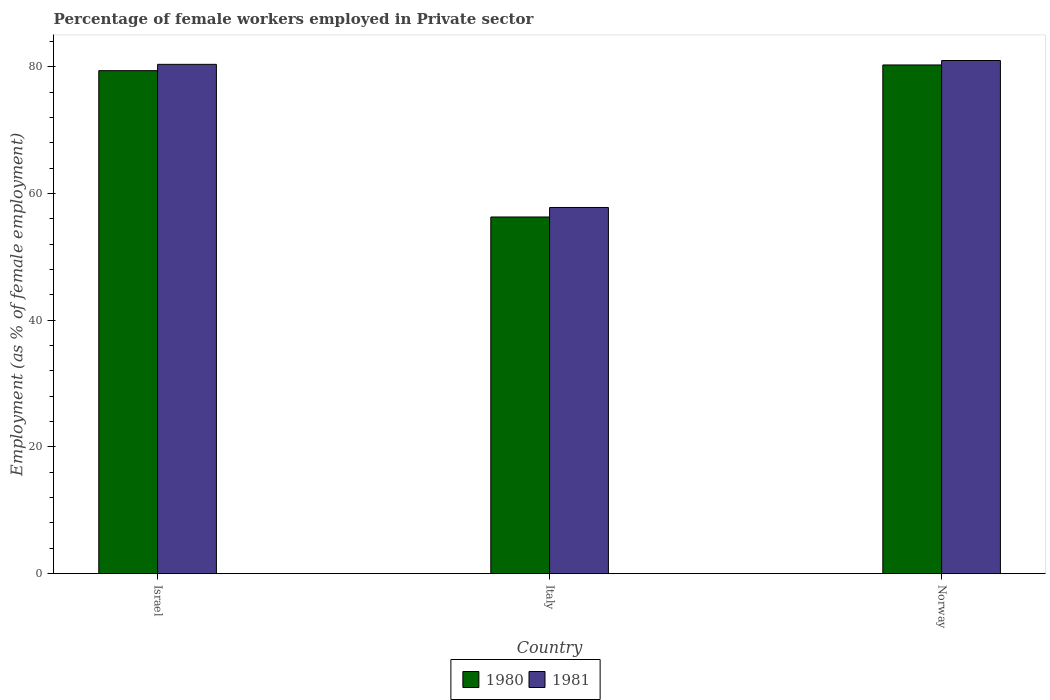How many groups of bars are there?
Offer a very short reply. 3. What is the label of the 1st group of bars from the left?
Your response must be concise. Israel. Across all countries, what is the maximum percentage of females employed in Private sector in 1980?
Provide a succinct answer. 80.3. Across all countries, what is the minimum percentage of females employed in Private sector in 1981?
Offer a terse response. 57.8. In which country was the percentage of females employed in Private sector in 1980 minimum?
Provide a succinct answer. Italy. What is the total percentage of females employed in Private sector in 1980 in the graph?
Make the answer very short. 216. What is the difference between the percentage of females employed in Private sector in 1980 in Israel and that in Norway?
Provide a succinct answer. -0.9. What is the difference between the percentage of females employed in Private sector in 1980 in Italy and the percentage of females employed in Private sector in 1981 in Israel?
Provide a short and direct response. -24.1. What is the average percentage of females employed in Private sector in 1981 per country?
Offer a very short reply. 73.07. What is the difference between the percentage of females employed in Private sector of/in 1981 and percentage of females employed in Private sector of/in 1980 in Norway?
Your answer should be very brief. 0.7. What is the ratio of the percentage of females employed in Private sector in 1980 in Italy to that in Norway?
Offer a very short reply. 0.7. What is the difference between the highest and the second highest percentage of females employed in Private sector in 1981?
Your answer should be compact. -0.6. What is the difference between the highest and the lowest percentage of females employed in Private sector in 1981?
Your answer should be very brief. 23.2. Is the sum of the percentage of females employed in Private sector in 1981 in Italy and Norway greater than the maximum percentage of females employed in Private sector in 1980 across all countries?
Offer a terse response. Yes. What does the 2nd bar from the right in Israel represents?
Offer a terse response. 1980. How many bars are there?
Ensure brevity in your answer.  6. Are all the bars in the graph horizontal?
Your answer should be compact. No. How many countries are there in the graph?
Ensure brevity in your answer.  3. Does the graph contain any zero values?
Offer a terse response. No. Where does the legend appear in the graph?
Your response must be concise. Bottom center. How many legend labels are there?
Keep it short and to the point. 2. What is the title of the graph?
Offer a terse response. Percentage of female workers employed in Private sector. Does "2006" appear as one of the legend labels in the graph?
Provide a succinct answer. No. What is the label or title of the X-axis?
Your answer should be compact. Country. What is the label or title of the Y-axis?
Keep it short and to the point. Employment (as % of female employment). What is the Employment (as % of female employment) of 1980 in Israel?
Provide a succinct answer. 79.4. What is the Employment (as % of female employment) in 1981 in Israel?
Offer a very short reply. 80.4. What is the Employment (as % of female employment) of 1980 in Italy?
Provide a succinct answer. 56.3. What is the Employment (as % of female employment) in 1981 in Italy?
Offer a terse response. 57.8. What is the Employment (as % of female employment) in 1980 in Norway?
Ensure brevity in your answer.  80.3. What is the Employment (as % of female employment) of 1981 in Norway?
Make the answer very short. 81. Across all countries, what is the maximum Employment (as % of female employment) in 1980?
Your response must be concise. 80.3. Across all countries, what is the minimum Employment (as % of female employment) in 1980?
Provide a succinct answer. 56.3. Across all countries, what is the minimum Employment (as % of female employment) in 1981?
Offer a terse response. 57.8. What is the total Employment (as % of female employment) of 1980 in the graph?
Provide a short and direct response. 216. What is the total Employment (as % of female employment) of 1981 in the graph?
Your answer should be very brief. 219.2. What is the difference between the Employment (as % of female employment) in 1980 in Israel and that in Italy?
Give a very brief answer. 23.1. What is the difference between the Employment (as % of female employment) in 1981 in Israel and that in Italy?
Ensure brevity in your answer.  22.6. What is the difference between the Employment (as % of female employment) of 1981 in Israel and that in Norway?
Ensure brevity in your answer.  -0.6. What is the difference between the Employment (as % of female employment) of 1980 in Italy and that in Norway?
Offer a terse response. -24. What is the difference between the Employment (as % of female employment) in 1981 in Italy and that in Norway?
Your response must be concise. -23.2. What is the difference between the Employment (as % of female employment) of 1980 in Israel and the Employment (as % of female employment) of 1981 in Italy?
Keep it short and to the point. 21.6. What is the difference between the Employment (as % of female employment) in 1980 in Israel and the Employment (as % of female employment) in 1981 in Norway?
Your response must be concise. -1.6. What is the difference between the Employment (as % of female employment) of 1980 in Italy and the Employment (as % of female employment) of 1981 in Norway?
Offer a very short reply. -24.7. What is the average Employment (as % of female employment) of 1980 per country?
Make the answer very short. 72. What is the average Employment (as % of female employment) of 1981 per country?
Keep it short and to the point. 73.07. What is the difference between the Employment (as % of female employment) in 1980 and Employment (as % of female employment) in 1981 in Israel?
Offer a terse response. -1. What is the difference between the Employment (as % of female employment) of 1980 and Employment (as % of female employment) of 1981 in Italy?
Offer a very short reply. -1.5. What is the ratio of the Employment (as % of female employment) of 1980 in Israel to that in Italy?
Give a very brief answer. 1.41. What is the ratio of the Employment (as % of female employment) of 1981 in Israel to that in Italy?
Make the answer very short. 1.39. What is the ratio of the Employment (as % of female employment) of 1980 in Israel to that in Norway?
Your answer should be very brief. 0.99. What is the ratio of the Employment (as % of female employment) of 1980 in Italy to that in Norway?
Offer a very short reply. 0.7. What is the ratio of the Employment (as % of female employment) in 1981 in Italy to that in Norway?
Provide a short and direct response. 0.71. What is the difference between the highest and the lowest Employment (as % of female employment) of 1980?
Provide a short and direct response. 24. What is the difference between the highest and the lowest Employment (as % of female employment) in 1981?
Your answer should be very brief. 23.2. 